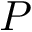Convert formula to latex. <formula><loc_0><loc_0><loc_500><loc_500>P</formula> 